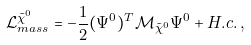Convert formula to latex. <formula><loc_0><loc_0><loc_500><loc_500>\mathcal { L } _ { m a s s } ^ { \tilde { \chi } ^ { 0 } } = - \frac { 1 } { 2 } ( \Psi ^ { 0 } ) ^ { T } \mathcal { M } _ { \tilde { \chi } ^ { 0 } } \Psi ^ { 0 } + H . c . \, ,</formula> 